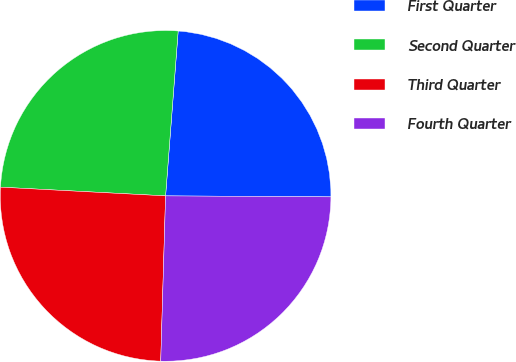<chart> <loc_0><loc_0><loc_500><loc_500><pie_chart><fcel>First Quarter<fcel>Second Quarter<fcel>Third Quarter<fcel>Fourth Quarter<nl><fcel>23.88%<fcel>25.37%<fcel>25.37%<fcel>25.37%<nl></chart> 